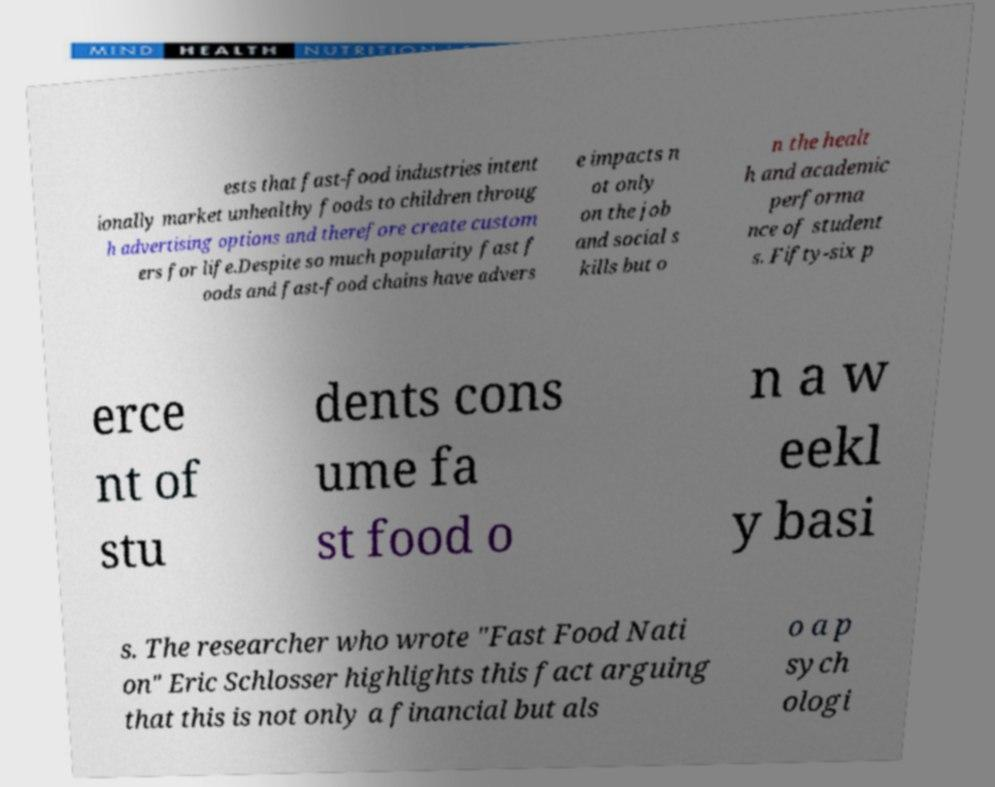Could you extract and type out the text from this image? ests that fast-food industries intent ionally market unhealthy foods to children throug h advertising options and therefore create custom ers for life.Despite so much popularity fast f oods and fast-food chains have advers e impacts n ot only on the job and social s kills but o n the healt h and academic performa nce of student s. Fifty-six p erce nt of stu dents cons ume fa st food o n a w eekl y basi s. The researcher who wrote "Fast Food Nati on" Eric Schlosser highlights this fact arguing that this is not only a financial but als o a p sych ologi 